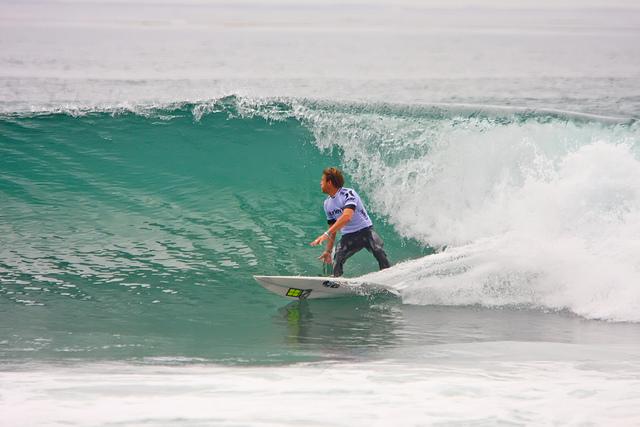What color is this person's shirt?
Quick response, please. Blue. Is this person paragliding?
Be succinct. No. What is the man doing?
Quick response, please. Surfing. What is the man riding?
Write a very short answer. Surfboard. Is this water dangerous?
Be succinct. No. What color is the surfboard?
Quick response, please. White. 